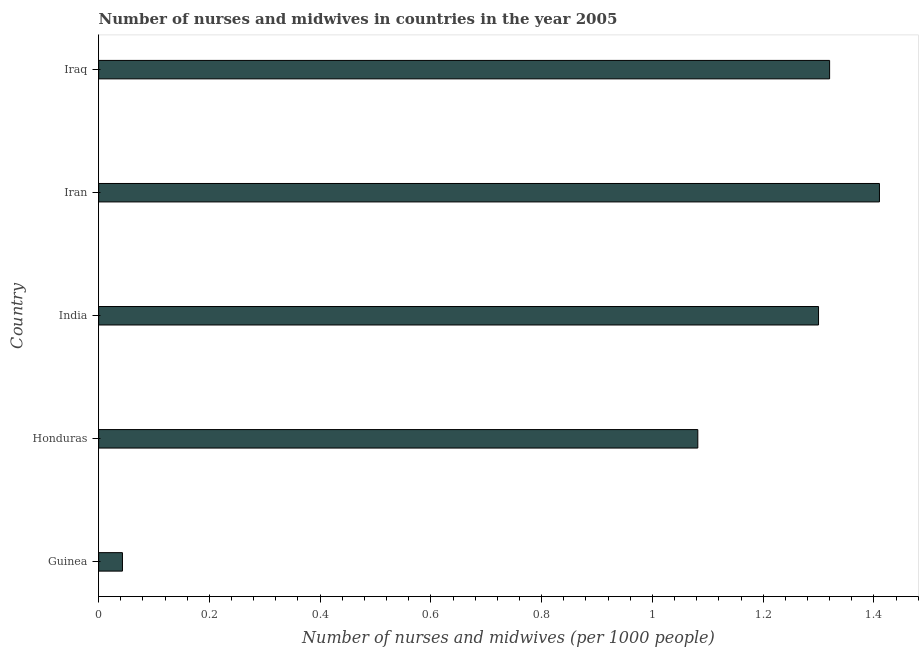Does the graph contain any zero values?
Your answer should be compact. No. What is the title of the graph?
Keep it short and to the point. Number of nurses and midwives in countries in the year 2005. What is the label or title of the X-axis?
Your answer should be compact. Number of nurses and midwives (per 1000 people). What is the label or title of the Y-axis?
Your answer should be compact. Country. What is the number of nurses and midwives in Guinea?
Give a very brief answer. 0.04. Across all countries, what is the maximum number of nurses and midwives?
Offer a very short reply. 1.41. Across all countries, what is the minimum number of nurses and midwives?
Offer a terse response. 0.04. In which country was the number of nurses and midwives maximum?
Your response must be concise. Iran. In which country was the number of nurses and midwives minimum?
Your response must be concise. Guinea. What is the sum of the number of nurses and midwives?
Offer a very short reply. 5.16. What is the difference between the number of nurses and midwives in India and Iran?
Ensure brevity in your answer.  -0.11. What is the average number of nurses and midwives per country?
Offer a very short reply. 1.03. What is the median number of nurses and midwives?
Offer a very short reply. 1.3. In how many countries, is the number of nurses and midwives greater than 0.56 ?
Make the answer very short. 4. Is the number of nurses and midwives in Iran less than that in Iraq?
Give a very brief answer. No. What is the difference between the highest and the second highest number of nurses and midwives?
Offer a terse response. 0.09. Is the sum of the number of nurses and midwives in Honduras and Iran greater than the maximum number of nurses and midwives across all countries?
Your answer should be compact. Yes. What is the difference between the highest and the lowest number of nurses and midwives?
Provide a short and direct response. 1.37. In how many countries, is the number of nurses and midwives greater than the average number of nurses and midwives taken over all countries?
Provide a succinct answer. 4. Are the values on the major ticks of X-axis written in scientific E-notation?
Ensure brevity in your answer.  No. What is the Number of nurses and midwives (per 1000 people) of Guinea?
Provide a short and direct response. 0.04. What is the Number of nurses and midwives (per 1000 people) in Honduras?
Make the answer very short. 1.08. What is the Number of nurses and midwives (per 1000 people) of India?
Ensure brevity in your answer.  1.3. What is the Number of nurses and midwives (per 1000 people) in Iran?
Give a very brief answer. 1.41. What is the Number of nurses and midwives (per 1000 people) of Iraq?
Your answer should be very brief. 1.32. What is the difference between the Number of nurses and midwives (per 1000 people) in Guinea and Honduras?
Your answer should be compact. -1.04. What is the difference between the Number of nurses and midwives (per 1000 people) in Guinea and India?
Offer a very short reply. -1.26. What is the difference between the Number of nurses and midwives (per 1000 people) in Guinea and Iran?
Make the answer very short. -1.37. What is the difference between the Number of nurses and midwives (per 1000 people) in Guinea and Iraq?
Give a very brief answer. -1.28. What is the difference between the Number of nurses and midwives (per 1000 people) in Honduras and India?
Offer a very short reply. -0.22. What is the difference between the Number of nurses and midwives (per 1000 people) in Honduras and Iran?
Offer a very short reply. -0.33. What is the difference between the Number of nurses and midwives (per 1000 people) in Honduras and Iraq?
Your answer should be very brief. -0.24. What is the difference between the Number of nurses and midwives (per 1000 people) in India and Iran?
Your answer should be compact. -0.11. What is the difference between the Number of nurses and midwives (per 1000 people) in India and Iraq?
Offer a very short reply. -0.02. What is the difference between the Number of nurses and midwives (per 1000 people) in Iran and Iraq?
Make the answer very short. 0.09. What is the ratio of the Number of nurses and midwives (per 1000 people) in Guinea to that in Honduras?
Your answer should be compact. 0.04. What is the ratio of the Number of nurses and midwives (per 1000 people) in Guinea to that in India?
Keep it short and to the point. 0.03. What is the ratio of the Number of nurses and midwives (per 1000 people) in Guinea to that in Iraq?
Provide a succinct answer. 0.03. What is the ratio of the Number of nurses and midwives (per 1000 people) in Honduras to that in India?
Your answer should be very brief. 0.83. What is the ratio of the Number of nurses and midwives (per 1000 people) in Honduras to that in Iran?
Give a very brief answer. 0.77. What is the ratio of the Number of nurses and midwives (per 1000 people) in Honduras to that in Iraq?
Ensure brevity in your answer.  0.82. What is the ratio of the Number of nurses and midwives (per 1000 people) in India to that in Iran?
Your response must be concise. 0.92. What is the ratio of the Number of nurses and midwives (per 1000 people) in India to that in Iraq?
Make the answer very short. 0.98. What is the ratio of the Number of nurses and midwives (per 1000 people) in Iran to that in Iraq?
Provide a succinct answer. 1.07. 